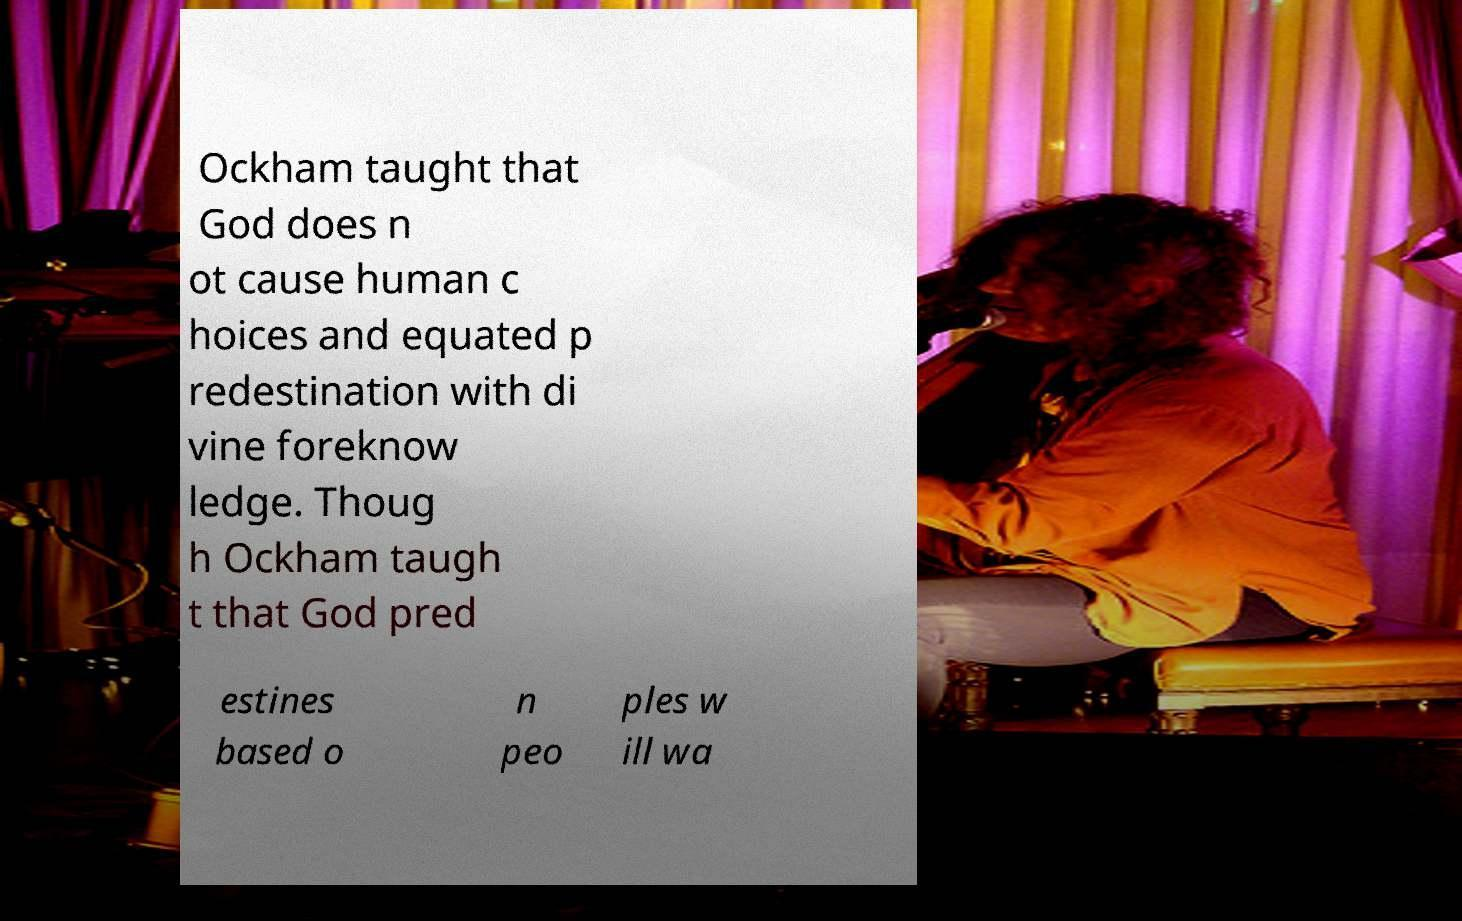I need the written content from this picture converted into text. Can you do that? Ockham taught that God does n ot cause human c hoices and equated p redestination with di vine foreknow ledge. Thoug h Ockham taugh t that God pred estines based o n peo ples w ill wa 